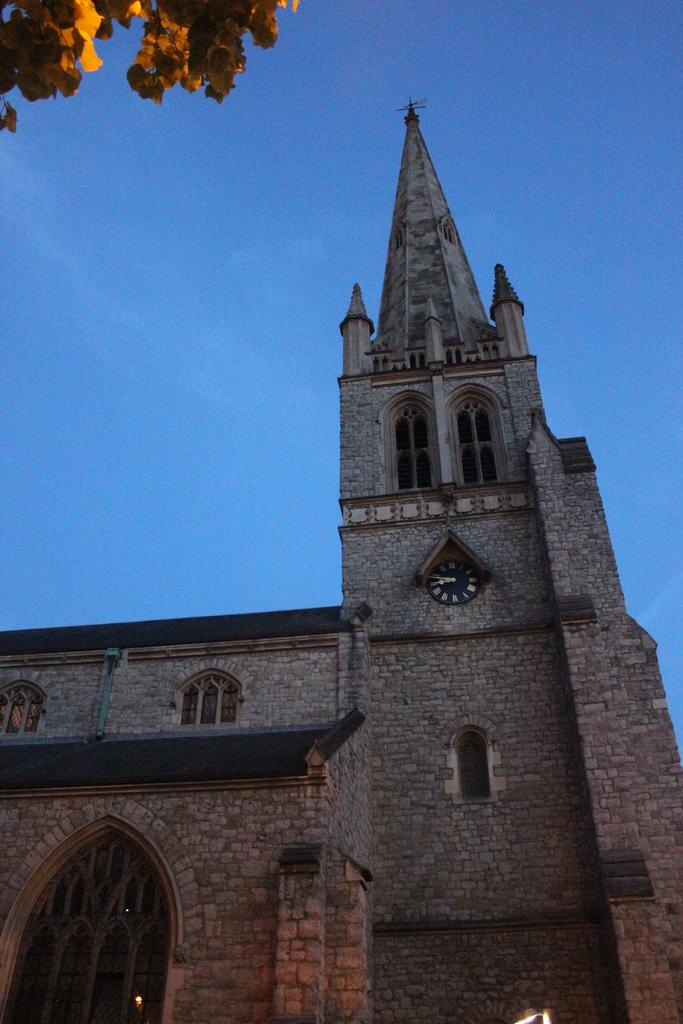What is located at the bottom of the image? There is a building at the bottom of the image. What can be seen at the top of the image? The sky is visible at the top of the image. Are there any natural elements present in the image? Yes, a few leaves are visible in the top left corner of the image. What type of work is being done on the building in the image? There is no indication of any work being done on the building in the image. 